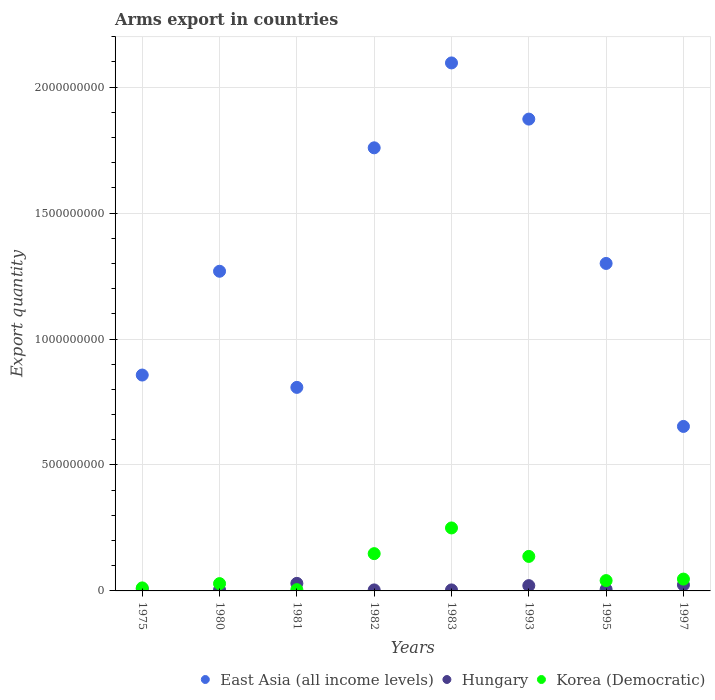What is the total arms export in Korea (Democratic) in 1975?
Your response must be concise. 1.20e+07. Across all years, what is the maximum total arms export in Korea (Democratic)?
Provide a succinct answer. 2.50e+08. Across all years, what is the minimum total arms export in Hungary?
Make the answer very short. 4.00e+06. In which year was the total arms export in East Asia (all income levels) minimum?
Your answer should be very brief. 1997. What is the total total arms export in Korea (Democratic) in the graph?
Give a very brief answer. 6.69e+08. What is the difference between the total arms export in Korea (Democratic) in 1993 and that in 1995?
Provide a succinct answer. 9.60e+07. What is the average total arms export in East Asia (all income levels) per year?
Give a very brief answer. 1.33e+09. In the year 1983, what is the difference between the total arms export in Korea (Democratic) and total arms export in Hungary?
Keep it short and to the point. 2.46e+08. In how many years, is the total arms export in Hungary greater than 500000000?
Your response must be concise. 0. What is the ratio of the total arms export in Hungary in 1980 to that in 1995?
Provide a short and direct response. 0.67. Is the total arms export in Korea (Democratic) in 1981 less than that in 1982?
Offer a very short reply. Yes. What is the difference between the highest and the second highest total arms export in Hungary?
Your answer should be compact. 6.00e+06. What is the difference between the highest and the lowest total arms export in Hungary?
Offer a terse response. 2.60e+07. In how many years, is the total arms export in Korea (Democratic) greater than the average total arms export in Korea (Democratic) taken over all years?
Your answer should be compact. 3. Is it the case that in every year, the sum of the total arms export in Hungary and total arms export in East Asia (all income levels)  is greater than the total arms export in Korea (Democratic)?
Your answer should be compact. Yes. Is the total arms export in East Asia (all income levels) strictly less than the total arms export in Hungary over the years?
Offer a very short reply. No. How many years are there in the graph?
Ensure brevity in your answer.  8. What is the difference between two consecutive major ticks on the Y-axis?
Provide a succinct answer. 5.00e+08. Are the values on the major ticks of Y-axis written in scientific E-notation?
Give a very brief answer. No. Does the graph contain any zero values?
Provide a succinct answer. No. How are the legend labels stacked?
Your answer should be compact. Horizontal. What is the title of the graph?
Provide a short and direct response. Arms export in countries. Does "Cayman Islands" appear as one of the legend labels in the graph?
Ensure brevity in your answer.  No. What is the label or title of the X-axis?
Offer a very short reply. Years. What is the label or title of the Y-axis?
Ensure brevity in your answer.  Export quantity. What is the Export quantity in East Asia (all income levels) in 1975?
Offer a terse response. 8.57e+08. What is the Export quantity in Hungary in 1975?
Offer a terse response. 8.00e+06. What is the Export quantity of East Asia (all income levels) in 1980?
Offer a very short reply. 1.27e+09. What is the Export quantity of Hungary in 1980?
Your response must be concise. 4.00e+06. What is the Export quantity of Korea (Democratic) in 1980?
Provide a succinct answer. 2.90e+07. What is the Export quantity in East Asia (all income levels) in 1981?
Ensure brevity in your answer.  8.08e+08. What is the Export quantity of Hungary in 1981?
Make the answer very short. 3.00e+07. What is the Export quantity in East Asia (all income levels) in 1982?
Keep it short and to the point. 1.76e+09. What is the Export quantity in Hungary in 1982?
Your answer should be compact. 4.00e+06. What is the Export quantity in Korea (Democratic) in 1982?
Provide a short and direct response. 1.48e+08. What is the Export quantity in East Asia (all income levels) in 1983?
Make the answer very short. 2.10e+09. What is the Export quantity of Korea (Democratic) in 1983?
Offer a terse response. 2.50e+08. What is the Export quantity of East Asia (all income levels) in 1993?
Your response must be concise. 1.87e+09. What is the Export quantity in Hungary in 1993?
Offer a very short reply. 2.10e+07. What is the Export quantity in Korea (Democratic) in 1993?
Provide a short and direct response. 1.37e+08. What is the Export quantity in East Asia (all income levels) in 1995?
Make the answer very short. 1.30e+09. What is the Export quantity in Korea (Democratic) in 1995?
Give a very brief answer. 4.10e+07. What is the Export quantity of East Asia (all income levels) in 1997?
Your answer should be compact. 6.53e+08. What is the Export quantity of Hungary in 1997?
Provide a succinct answer. 2.40e+07. What is the Export quantity of Korea (Democratic) in 1997?
Give a very brief answer. 4.70e+07. Across all years, what is the maximum Export quantity of East Asia (all income levels)?
Offer a very short reply. 2.10e+09. Across all years, what is the maximum Export quantity in Hungary?
Your response must be concise. 3.00e+07. Across all years, what is the maximum Export quantity of Korea (Democratic)?
Your response must be concise. 2.50e+08. Across all years, what is the minimum Export quantity in East Asia (all income levels)?
Your answer should be very brief. 6.53e+08. Across all years, what is the minimum Export quantity in Korea (Democratic)?
Your response must be concise. 5.00e+06. What is the total Export quantity of East Asia (all income levels) in the graph?
Provide a short and direct response. 1.06e+1. What is the total Export quantity in Hungary in the graph?
Make the answer very short. 1.01e+08. What is the total Export quantity in Korea (Democratic) in the graph?
Provide a succinct answer. 6.69e+08. What is the difference between the Export quantity in East Asia (all income levels) in 1975 and that in 1980?
Offer a terse response. -4.12e+08. What is the difference between the Export quantity in Hungary in 1975 and that in 1980?
Provide a succinct answer. 4.00e+06. What is the difference between the Export quantity of Korea (Democratic) in 1975 and that in 1980?
Ensure brevity in your answer.  -1.70e+07. What is the difference between the Export quantity in East Asia (all income levels) in 1975 and that in 1981?
Ensure brevity in your answer.  4.90e+07. What is the difference between the Export quantity in Hungary in 1975 and that in 1981?
Offer a terse response. -2.20e+07. What is the difference between the Export quantity in Korea (Democratic) in 1975 and that in 1981?
Offer a very short reply. 7.00e+06. What is the difference between the Export quantity in East Asia (all income levels) in 1975 and that in 1982?
Give a very brief answer. -9.02e+08. What is the difference between the Export quantity in Korea (Democratic) in 1975 and that in 1982?
Keep it short and to the point. -1.36e+08. What is the difference between the Export quantity in East Asia (all income levels) in 1975 and that in 1983?
Give a very brief answer. -1.24e+09. What is the difference between the Export quantity of Korea (Democratic) in 1975 and that in 1983?
Your answer should be very brief. -2.38e+08. What is the difference between the Export quantity of East Asia (all income levels) in 1975 and that in 1993?
Keep it short and to the point. -1.02e+09. What is the difference between the Export quantity in Hungary in 1975 and that in 1993?
Your answer should be compact. -1.30e+07. What is the difference between the Export quantity of Korea (Democratic) in 1975 and that in 1993?
Your answer should be very brief. -1.25e+08. What is the difference between the Export quantity in East Asia (all income levels) in 1975 and that in 1995?
Your answer should be compact. -4.43e+08. What is the difference between the Export quantity in Hungary in 1975 and that in 1995?
Offer a very short reply. 2.00e+06. What is the difference between the Export quantity of Korea (Democratic) in 1975 and that in 1995?
Provide a short and direct response. -2.90e+07. What is the difference between the Export quantity of East Asia (all income levels) in 1975 and that in 1997?
Make the answer very short. 2.04e+08. What is the difference between the Export quantity in Hungary in 1975 and that in 1997?
Provide a short and direct response. -1.60e+07. What is the difference between the Export quantity in Korea (Democratic) in 1975 and that in 1997?
Keep it short and to the point. -3.50e+07. What is the difference between the Export quantity of East Asia (all income levels) in 1980 and that in 1981?
Make the answer very short. 4.61e+08. What is the difference between the Export quantity in Hungary in 1980 and that in 1981?
Make the answer very short. -2.60e+07. What is the difference between the Export quantity of Korea (Democratic) in 1980 and that in 1981?
Make the answer very short. 2.40e+07. What is the difference between the Export quantity in East Asia (all income levels) in 1980 and that in 1982?
Your answer should be very brief. -4.90e+08. What is the difference between the Export quantity in Korea (Democratic) in 1980 and that in 1982?
Your answer should be very brief. -1.19e+08. What is the difference between the Export quantity of East Asia (all income levels) in 1980 and that in 1983?
Offer a very short reply. -8.27e+08. What is the difference between the Export quantity of Hungary in 1980 and that in 1983?
Give a very brief answer. 0. What is the difference between the Export quantity in Korea (Democratic) in 1980 and that in 1983?
Offer a terse response. -2.21e+08. What is the difference between the Export quantity in East Asia (all income levels) in 1980 and that in 1993?
Provide a succinct answer. -6.04e+08. What is the difference between the Export quantity in Hungary in 1980 and that in 1993?
Your response must be concise. -1.70e+07. What is the difference between the Export quantity of Korea (Democratic) in 1980 and that in 1993?
Offer a terse response. -1.08e+08. What is the difference between the Export quantity of East Asia (all income levels) in 1980 and that in 1995?
Offer a terse response. -3.10e+07. What is the difference between the Export quantity of Hungary in 1980 and that in 1995?
Your response must be concise. -2.00e+06. What is the difference between the Export quantity of Korea (Democratic) in 1980 and that in 1995?
Your answer should be compact. -1.20e+07. What is the difference between the Export quantity in East Asia (all income levels) in 1980 and that in 1997?
Ensure brevity in your answer.  6.16e+08. What is the difference between the Export quantity of Hungary in 1980 and that in 1997?
Provide a succinct answer. -2.00e+07. What is the difference between the Export quantity in Korea (Democratic) in 1980 and that in 1997?
Your answer should be compact. -1.80e+07. What is the difference between the Export quantity in East Asia (all income levels) in 1981 and that in 1982?
Offer a terse response. -9.51e+08. What is the difference between the Export quantity in Hungary in 1981 and that in 1982?
Keep it short and to the point. 2.60e+07. What is the difference between the Export quantity of Korea (Democratic) in 1981 and that in 1982?
Your answer should be compact. -1.43e+08. What is the difference between the Export quantity in East Asia (all income levels) in 1981 and that in 1983?
Make the answer very short. -1.29e+09. What is the difference between the Export quantity of Hungary in 1981 and that in 1983?
Offer a very short reply. 2.60e+07. What is the difference between the Export quantity of Korea (Democratic) in 1981 and that in 1983?
Provide a succinct answer. -2.45e+08. What is the difference between the Export quantity in East Asia (all income levels) in 1981 and that in 1993?
Offer a terse response. -1.06e+09. What is the difference between the Export quantity of Hungary in 1981 and that in 1993?
Make the answer very short. 9.00e+06. What is the difference between the Export quantity of Korea (Democratic) in 1981 and that in 1993?
Give a very brief answer. -1.32e+08. What is the difference between the Export quantity of East Asia (all income levels) in 1981 and that in 1995?
Provide a short and direct response. -4.92e+08. What is the difference between the Export quantity in Hungary in 1981 and that in 1995?
Provide a short and direct response. 2.40e+07. What is the difference between the Export quantity in Korea (Democratic) in 1981 and that in 1995?
Your answer should be compact. -3.60e+07. What is the difference between the Export quantity in East Asia (all income levels) in 1981 and that in 1997?
Ensure brevity in your answer.  1.55e+08. What is the difference between the Export quantity of Korea (Democratic) in 1981 and that in 1997?
Give a very brief answer. -4.20e+07. What is the difference between the Export quantity of East Asia (all income levels) in 1982 and that in 1983?
Offer a terse response. -3.37e+08. What is the difference between the Export quantity of Hungary in 1982 and that in 1983?
Your answer should be compact. 0. What is the difference between the Export quantity in Korea (Democratic) in 1982 and that in 1983?
Your response must be concise. -1.02e+08. What is the difference between the Export quantity of East Asia (all income levels) in 1982 and that in 1993?
Ensure brevity in your answer.  -1.14e+08. What is the difference between the Export quantity in Hungary in 1982 and that in 1993?
Offer a very short reply. -1.70e+07. What is the difference between the Export quantity of Korea (Democratic) in 1982 and that in 1993?
Your response must be concise. 1.10e+07. What is the difference between the Export quantity in East Asia (all income levels) in 1982 and that in 1995?
Offer a very short reply. 4.59e+08. What is the difference between the Export quantity of Korea (Democratic) in 1982 and that in 1995?
Your answer should be compact. 1.07e+08. What is the difference between the Export quantity of East Asia (all income levels) in 1982 and that in 1997?
Your answer should be compact. 1.11e+09. What is the difference between the Export quantity in Hungary in 1982 and that in 1997?
Your answer should be very brief. -2.00e+07. What is the difference between the Export quantity of Korea (Democratic) in 1982 and that in 1997?
Provide a short and direct response. 1.01e+08. What is the difference between the Export quantity in East Asia (all income levels) in 1983 and that in 1993?
Your answer should be compact. 2.23e+08. What is the difference between the Export quantity in Hungary in 1983 and that in 1993?
Offer a terse response. -1.70e+07. What is the difference between the Export quantity of Korea (Democratic) in 1983 and that in 1993?
Offer a terse response. 1.13e+08. What is the difference between the Export quantity in East Asia (all income levels) in 1983 and that in 1995?
Offer a very short reply. 7.96e+08. What is the difference between the Export quantity of Korea (Democratic) in 1983 and that in 1995?
Provide a succinct answer. 2.09e+08. What is the difference between the Export quantity of East Asia (all income levels) in 1983 and that in 1997?
Offer a terse response. 1.44e+09. What is the difference between the Export quantity of Hungary in 1983 and that in 1997?
Offer a terse response. -2.00e+07. What is the difference between the Export quantity of Korea (Democratic) in 1983 and that in 1997?
Ensure brevity in your answer.  2.03e+08. What is the difference between the Export quantity in East Asia (all income levels) in 1993 and that in 1995?
Make the answer very short. 5.73e+08. What is the difference between the Export quantity in Hungary in 1993 and that in 1995?
Your answer should be very brief. 1.50e+07. What is the difference between the Export quantity in Korea (Democratic) in 1993 and that in 1995?
Provide a short and direct response. 9.60e+07. What is the difference between the Export quantity of East Asia (all income levels) in 1993 and that in 1997?
Keep it short and to the point. 1.22e+09. What is the difference between the Export quantity in Hungary in 1993 and that in 1997?
Keep it short and to the point. -3.00e+06. What is the difference between the Export quantity of Korea (Democratic) in 1993 and that in 1997?
Make the answer very short. 9.00e+07. What is the difference between the Export quantity of East Asia (all income levels) in 1995 and that in 1997?
Offer a very short reply. 6.47e+08. What is the difference between the Export quantity of Hungary in 1995 and that in 1997?
Provide a succinct answer. -1.80e+07. What is the difference between the Export quantity of Korea (Democratic) in 1995 and that in 1997?
Ensure brevity in your answer.  -6.00e+06. What is the difference between the Export quantity in East Asia (all income levels) in 1975 and the Export quantity in Hungary in 1980?
Offer a terse response. 8.53e+08. What is the difference between the Export quantity of East Asia (all income levels) in 1975 and the Export quantity of Korea (Democratic) in 1980?
Make the answer very short. 8.28e+08. What is the difference between the Export quantity of Hungary in 1975 and the Export quantity of Korea (Democratic) in 1980?
Offer a terse response. -2.10e+07. What is the difference between the Export quantity in East Asia (all income levels) in 1975 and the Export quantity in Hungary in 1981?
Give a very brief answer. 8.27e+08. What is the difference between the Export quantity of East Asia (all income levels) in 1975 and the Export quantity of Korea (Democratic) in 1981?
Offer a very short reply. 8.52e+08. What is the difference between the Export quantity of Hungary in 1975 and the Export quantity of Korea (Democratic) in 1981?
Your response must be concise. 3.00e+06. What is the difference between the Export quantity in East Asia (all income levels) in 1975 and the Export quantity in Hungary in 1982?
Offer a terse response. 8.53e+08. What is the difference between the Export quantity in East Asia (all income levels) in 1975 and the Export quantity in Korea (Democratic) in 1982?
Provide a succinct answer. 7.09e+08. What is the difference between the Export quantity of Hungary in 1975 and the Export quantity of Korea (Democratic) in 1982?
Provide a succinct answer. -1.40e+08. What is the difference between the Export quantity of East Asia (all income levels) in 1975 and the Export quantity of Hungary in 1983?
Give a very brief answer. 8.53e+08. What is the difference between the Export quantity in East Asia (all income levels) in 1975 and the Export quantity in Korea (Democratic) in 1983?
Offer a terse response. 6.07e+08. What is the difference between the Export quantity of Hungary in 1975 and the Export quantity of Korea (Democratic) in 1983?
Provide a succinct answer. -2.42e+08. What is the difference between the Export quantity in East Asia (all income levels) in 1975 and the Export quantity in Hungary in 1993?
Provide a short and direct response. 8.36e+08. What is the difference between the Export quantity in East Asia (all income levels) in 1975 and the Export quantity in Korea (Democratic) in 1993?
Your answer should be compact. 7.20e+08. What is the difference between the Export quantity of Hungary in 1975 and the Export quantity of Korea (Democratic) in 1993?
Offer a terse response. -1.29e+08. What is the difference between the Export quantity of East Asia (all income levels) in 1975 and the Export quantity of Hungary in 1995?
Your answer should be very brief. 8.51e+08. What is the difference between the Export quantity of East Asia (all income levels) in 1975 and the Export quantity of Korea (Democratic) in 1995?
Your answer should be compact. 8.16e+08. What is the difference between the Export quantity of Hungary in 1975 and the Export quantity of Korea (Democratic) in 1995?
Offer a very short reply. -3.30e+07. What is the difference between the Export quantity of East Asia (all income levels) in 1975 and the Export quantity of Hungary in 1997?
Your answer should be compact. 8.33e+08. What is the difference between the Export quantity of East Asia (all income levels) in 1975 and the Export quantity of Korea (Democratic) in 1997?
Offer a terse response. 8.10e+08. What is the difference between the Export quantity in Hungary in 1975 and the Export quantity in Korea (Democratic) in 1997?
Provide a succinct answer. -3.90e+07. What is the difference between the Export quantity in East Asia (all income levels) in 1980 and the Export quantity in Hungary in 1981?
Your answer should be very brief. 1.24e+09. What is the difference between the Export quantity in East Asia (all income levels) in 1980 and the Export quantity in Korea (Democratic) in 1981?
Offer a terse response. 1.26e+09. What is the difference between the Export quantity in East Asia (all income levels) in 1980 and the Export quantity in Hungary in 1982?
Provide a succinct answer. 1.26e+09. What is the difference between the Export quantity in East Asia (all income levels) in 1980 and the Export quantity in Korea (Democratic) in 1982?
Your answer should be compact. 1.12e+09. What is the difference between the Export quantity of Hungary in 1980 and the Export quantity of Korea (Democratic) in 1982?
Provide a succinct answer. -1.44e+08. What is the difference between the Export quantity of East Asia (all income levels) in 1980 and the Export quantity of Hungary in 1983?
Offer a terse response. 1.26e+09. What is the difference between the Export quantity in East Asia (all income levels) in 1980 and the Export quantity in Korea (Democratic) in 1983?
Your answer should be compact. 1.02e+09. What is the difference between the Export quantity of Hungary in 1980 and the Export quantity of Korea (Democratic) in 1983?
Your answer should be very brief. -2.46e+08. What is the difference between the Export quantity in East Asia (all income levels) in 1980 and the Export quantity in Hungary in 1993?
Keep it short and to the point. 1.25e+09. What is the difference between the Export quantity in East Asia (all income levels) in 1980 and the Export quantity in Korea (Democratic) in 1993?
Provide a short and direct response. 1.13e+09. What is the difference between the Export quantity in Hungary in 1980 and the Export quantity in Korea (Democratic) in 1993?
Keep it short and to the point. -1.33e+08. What is the difference between the Export quantity in East Asia (all income levels) in 1980 and the Export quantity in Hungary in 1995?
Make the answer very short. 1.26e+09. What is the difference between the Export quantity in East Asia (all income levels) in 1980 and the Export quantity in Korea (Democratic) in 1995?
Provide a short and direct response. 1.23e+09. What is the difference between the Export quantity in Hungary in 1980 and the Export quantity in Korea (Democratic) in 1995?
Your response must be concise. -3.70e+07. What is the difference between the Export quantity in East Asia (all income levels) in 1980 and the Export quantity in Hungary in 1997?
Give a very brief answer. 1.24e+09. What is the difference between the Export quantity of East Asia (all income levels) in 1980 and the Export quantity of Korea (Democratic) in 1997?
Your response must be concise. 1.22e+09. What is the difference between the Export quantity of Hungary in 1980 and the Export quantity of Korea (Democratic) in 1997?
Make the answer very short. -4.30e+07. What is the difference between the Export quantity in East Asia (all income levels) in 1981 and the Export quantity in Hungary in 1982?
Offer a very short reply. 8.04e+08. What is the difference between the Export quantity in East Asia (all income levels) in 1981 and the Export quantity in Korea (Democratic) in 1982?
Your answer should be very brief. 6.60e+08. What is the difference between the Export quantity in Hungary in 1981 and the Export quantity in Korea (Democratic) in 1982?
Make the answer very short. -1.18e+08. What is the difference between the Export quantity of East Asia (all income levels) in 1981 and the Export quantity of Hungary in 1983?
Make the answer very short. 8.04e+08. What is the difference between the Export quantity in East Asia (all income levels) in 1981 and the Export quantity in Korea (Democratic) in 1983?
Make the answer very short. 5.58e+08. What is the difference between the Export quantity of Hungary in 1981 and the Export quantity of Korea (Democratic) in 1983?
Make the answer very short. -2.20e+08. What is the difference between the Export quantity of East Asia (all income levels) in 1981 and the Export quantity of Hungary in 1993?
Provide a succinct answer. 7.87e+08. What is the difference between the Export quantity in East Asia (all income levels) in 1981 and the Export quantity in Korea (Democratic) in 1993?
Offer a terse response. 6.71e+08. What is the difference between the Export quantity in Hungary in 1981 and the Export quantity in Korea (Democratic) in 1993?
Your answer should be very brief. -1.07e+08. What is the difference between the Export quantity in East Asia (all income levels) in 1981 and the Export quantity in Hungary in 1995?
Your response must be concise. 8.02e+08. What is the difference between the Export quantity in East Asia (all income levels) in 1981 and the Export quantity in Korea (Democratic) in 1995?
Offer a terse response. 7.67e+08. What is the difference between the Export quantity in Hungary in 1981 and the Export quantity in Korea (Democratic) in 1995?
Offer a terse response. -1.10e+07. What is the difference between the Export quantity in East Asia (all income levels) in 1981 and the Export quantity in Hungary in 1997?
Your response must be concise. 7.84e+08. What is the difference between the Export quantity in East Asia (all income levels) in 1981 and the Export quantity in Korea (Democratic) in 1997?
Give a very brief answer. 7.61e+08. What is the difference between the Export quantity in Hungary in 1981 and the Export quantity in Korea (Democratic) in 1997?
Make the answer very short. -1.70e+07. What is the difference between the Export quantity in East Asia (all income levels) in 1982 and the Export quantity in Hungary in 1983?
Keep it short and to the point. 1.76e+09. What is the difference between the Export quantity in East Asia (all income levels) in 1982 and the Export quantity in Korea (Democratic) in 1983?
Make the answer very short. 1.51e+09. What is the difference between the Export quantity of Hungary in 1982 and the Export quantity of Korea (Democratic) in 1983?
Make the answer very short. -2.46e+08. What is the difference between the Export quantity in East Asia (all income levels) in 1982 and the Export quantity in Hungary in 1993?
Give a very brief answer. 1.74e+09. What is the difference between the Export quantity in East Asia (all income levels) in 1982 and the Export quantity in Korea (Democratic) in 1993?
Your response must be concise. 1.62e+09. What is the difference between the Export quantity in Hungary in 1982 and the Export quantity in Korea (Democratic) in 1993?
Offer a terse response. -1.33e+08. What is the difference between the Export quantity in East Asia (all income levels) in 1982 and the Export quantity in Hungary in 1995?
Your response must be concise. 1.75e+09. What is the difference between the Export quantity of East Asia (all income levels) in 1982 and the Export quantity of Korea (Democratic) in 1995?
Keep it short and to the point. 1.72e+09. What is the difference between the Export quantity of Hungary in 1982 and the Export quantity of Korea (Democratic) in 1995?
Ensure brevity in your answer.  -3.70e+07. What is the difference between the Export quantity in East Asia (all income levels) in 1982 and the Export quantity in Hungary in 1997?
Provide a succinct answer. 1.74e+09. What is the difference between the Export quantity in East Asia (all income levels) in 1982 and the Export quantity in Korea (Democratic) in 1997?
Your answer should be very brief. 1.71e+09. What is the difference between the Export quantity in Hungary in 1982 and the Export quantity in Korea (Democratic) in 1997?
Your response must be concise. -4.30e+07. What is the difference between the Export quantity of East Asia (all income levels) in 1983 and the Export quantity of Hungary in 1993?
Make the answer very short. 2.08e+09. What is the difference between the Export quantity in East Asia (all income levels) in 1983 and the Export quantity in Korea (Democratic) in 1993?
Your answer should be very brief. 1.96e+09. What is the difference between the Export quantity in Hungary in 1983 and the Export quantity in Korea (Democratic) in 1993?
Offer a terse response. -1.33e+08. What is the difference between the Export quantity in East Asia (all income levels) in 1983 and the Export quantity in Hungary in 1995?
Offer a terse response. 2.09e+09. What is the difference between the Export quantity of East Asia (all income levels) in 1983 and the Export quantity of Korea (Democratic) in 1995?
Your response must be concise. 2.06e+09. What is the difference between the Export quantity of Hungary in 1983 and the Export quantity of Korea (Democratic) in 1995?
Your answer should be compact. -3.70e+07. What is the difference between the Export quantity of East Asia (all income levels) in 1983 and the Export quantity of Hungary in 1997?
Offer a terse response. 2.07e+09. What is the difference between the Export quantity of East Asia (all income levels) in 1983 and the Export quantity of Korea (Democratic) in 1997?
Offer a very short reply. 2.05e+09. What is the difference between the Export quantity in Hungary in 1983 and the Export quantity in Korea (Democratic) in 1997?
Your answer should be compact. -4.30e+07. What is the difference between the Export quantity of East Asia (all income levels) in 1993 and the Export quantity of Hungary in 1995?
Offer a very short reply. 1.87e+09. What is the difference between the Export quantity of East Asia (all income levels) in 1993 and the Export quantity of Korea (Democratic) in 1995?
Ensure brevity in your answer.  1.83e+09. What is the difference between the Export quantity in Hungary in 1993 and the Export quantity in Korea (Democratic) in 1995?
Ensure brevity in your answer.  -2.00e+07. What is the difference between the Export quantity in East Asia (all income levels) in 1993 and the Export quantity in Hungary in 1997?
Offer a terse response. 1.85e+09. What is the difference between the Export quantity of East Asia (all income levels) in 1993 and the Export quantity of Korea (Democratic) in 1997?
Your answer should be compact. 1.83e+09. What is the difference between the Export quantity in Hungary in 1993 and the Export quantity in Korea (Democratic) in 1997?
Your answer should be very brief. -2.60e+07. What is the difference between the Export quantity in East Asia (all income levels) in 1995 and the Export quantity in Hungary in 1997?
Keep it short and to the point. 1.28e+09. What is the difference between the Export quantity of East Asia (all income levels) in 1995 and the Export quantity of Korea (Democratic) in 1997?
Provide a succinct answer. 1.25e+09. What is the difference between the Export quantity of Hungary in 1995 and the Export quantity of Korea (Democratic) in 1997?
Offer a very short reply. -4.10e+07. What is the average Export quantity of East Asia (all income levels) per year?
Your response must be concise. 1.33e+09. What is the average Export quantity in Hungary per year?
Provide a succinct answer. 1.26e+07. What is the average Export quantity of Korea (Democratic) per year?
Make the answer very short. 8.36e+07. In the year 1975, what is the difference between the Export quantity of East Asia (all income levels) and Export quantity of Hungary?
Provide a short and direct response. 8.49e+08. In the year 1975, what is the difference between the Export quantity of East Asia (all income levels) and Export quantity of Korea (Democratic)?
Keep it short and to the point. 8.45e+08. In the year 1975, what is the difference between the Export quantity in Hungary and Export quantity in Korea (Democratic)?
Your answer should be very brief. -4.00e+06. In the year 1980, what is the difference between the Export quantity of East Asia (all income levels) and Export quantity of Hungary?
Offer a very short reply. 1.26e+09. In the year 1980, what is the difference between the Export quantity in East Asia (all income levels) and Export quantity in Korea (Democratic)?
Offer a very short reply. 1.24e+09. In the year 1980, what is the difference between the Export quantity in Hungary and Export quantity in Korea (Democratic)?
Your answer should be compact. -2.50e+07. In the year 1981, what is the difference between the Export quantity of East Asia (all income levels) and Export quantity of Hungary?
Your answer should be compact. 7.78e+08. In the year 1981, what is the difference between the Export quantity in East Asia (all income levels) and Export quantity in Korea (Democratic)?
Offer a terse response. 8.03e+08. In the year 1981, what is the difference between the Export quantity in Hungary and Export quantity in Korea (Democratic)?
Make the answer very short. 2.50e+07. In the year 1982, what is the difference between the Export quantity of East Asia (all income levels) and Export quantity of Hungary?
Give a very brief answer. 1.76e+09. In the year 1982, what is the difference between the Export quantity of East Asia (all income levels) and Export quantity of Korea (Democratic)?
Offer a very short reply. 1.61e+09. In the year 1982, what is the difference between the Export quantity of Hungary and Export quantity of Korea (Democratic)?
Provide a succinct answer. -1.44e+08. In the year 1983, what is the difference between the Export quantity of East Asia (all income levels) and Export quantity of Hungary?
Your answer should be compact. 2.09e+09. In the year 1983, what is the difference between the Export quantity in East Asia (all income levels) and Export quantity in Korea (Democratic)?
Your answer should be compact. 1.85e+09. In the year 1983, what is the difference between the Export quantity of Hungary and Export quantity of Korea (Democratic)?
Make the answer very short. -2.46e+08. In the year 1993, what is the difference between the Export quantity in East Asia (all income levels) and Export quantity in Hungary?
Your answer should be compact. 1.85e+09. In the year 1993, what is the difference between the Export quantity in East Asia (all income levels) and Export quantity in Korea (Democratic)?
Your answer should be very brief. 1.74e+09. In the year 1993, what is the difference between the Export quantity of Hungary and Export quantity of Korea (Democratic)?
Your response must be concise. -1.16e+08. In the year 1995, what is the difference between the Export quantity in East Asia (all income levels) and Export quantity in Hungary?
Give a very brief answer. 1.29e+09. In the year 1995, what is the difference between the Export quantity of East Asia (all income levels) and Export quantity of Korea (Democratic)?
Offer a terse response. 1.26e+09. In the year 1995, what is the difference between the Export quantity of Hungary and Export quantity of Korea (Democratic)?
Offer a terse response. -3.50e+07. In the year 1997, what is the difference between the Export quantity in East Asia (all income levels) and Export quantity in Hungary?
Offer a very short reply. 6.29e+08. In the year 1997, what is the difference between the Export quantity of East Asia (all income levels) and Export quantity of Korea (Democratic)?
Keep it short and to the point. 6.06e+08. In the year 1997, what is the difference between the Export quantity of Hungary and Export quantity of Korea (Democratic)?
Offer a terse response. -2.30e+07. What is the ratio of the Export quantity in East Asia (all income levels) in 1975 to that in 1980?
Your answer should be very brief. 0.68. What is the ratio of the Export quantity in Hungary in 1975 to that in 1980?
Ensure brevity in your answer.  2. What is the ratio of the Export quantity of Korea (Democratic) in 1975 to that in 1980?
Your response must be concise. 0.41. What is the ratio of the Export quantity of East Asia (all income levels) in 1975 to that in 1981?
Give a very brief answer. 1.06. What is the ratio of the Export quantity of Hungary in 1975 to that in 1981?
Give a very brief answer. 0.27. What is the ratio of the Export quantity in Korea (Democratic) in 1975 to that in 1981?
Offer a terse response. 2.4. What is the ratio of the Export quantity in East Asia (all income levels) in 1975 to that in 1982?
Give a very brief answer. 0.49. What is the ratio of the Export quantity of Hungary in 1975 to that in 1982?
Your answer should be compact. 2. What is the ratio of the Export quantity of Korea (Democratic) in 1975 to that in 1982?
Keep it short and to the point. 0.08. What is the ratio of the Export quantity of East Asia (all income levels) in 1975 to that in 1983?
Your answer should be very brief. 0.41. What is the ratio of the Export quantity of Korea (Democratic) in 1975 to that in 1983?
Provide a short and direct response. 0.05. What is the ratio of the Export quantity in East Asia (all income levels) in 1975 to that in 1993?
Your response must be concise. 0.46. What is the ratio of the Export quantity of Hungary in 1975 to that in 1993?
Give a very brief answer. 0.38. What is the ratio of the Export quantity of Korea (Democratic) in 1975 to that in 1993?
Make the answer very short. 0.09. What is the ratio of the Export quantity in East Asia (all income levels) in 1975 to that in 1995?
Your response must be concise. 0.66. What is the ratio of the Export quantity in Hungary in 1975 to that in 1995?
Keep it short and to the point. 1.33. What is the ratio of the Export quantity in Korea (Democratic) in 1975 to that in 1995?
Provide a succinct answer. 0.29. What is the ratio of the Export quantity in East Asia (all income levels) in 1975 to that in 1997?
Your answer should be very brief. 1.31. What is the ratio of the Export quantity in Hungary in 1975 to that in 1997?
Offer a very short reply. 0.33. What is the ratio of the Export quantity in Korea (Democratic) in 1975 to that in 1997?
Ensure brevity in your answer.  0.26. What is the ratio of the Export quantity in East Asia (all income levels) in 1980 to that in 1981?
Make the answer very short. 1.57. What is the ratio of the Export quantity of Hungary in 1980 to that in 1981?
Your answer should be very brief. 0.13. What is the ratio of the Export quantity in East Asia (all income levels) in 1980 to that in 1982?
Offer a very short reply. 0.72. What is the ratio of the Export quantity in Korea (Democratic) in 1980 to that in 1982?
Ensure brevity in your answer.  0.2. What is the ratio of the Export quantity in East Asia (all income levels) in 1980 to that in 1983?
Offer a very short reply. 0.61. What is the ratio of the Export quantity in Korea (Democratic) in 1980 to that in 1983?
Your response must be concise. 0.12. What is the ratio of the Export quantity of East Asia (all income levels) in 1980 to that in 1993?
Keep it short and to the point. 0.68. What is the ratio of the Export quantity in Hungary in 1980 to that in 1993?
Ensure brevity in your answer.  0.19. What is the ratio of the Export quantity in Korea (Democratic) in 1980 to that in 1993?
Your answer should be very brief. 0.21. What is the ratio of the Export quantity of East Asia (all income levels) in 1980 to that in 1995?
Your response must be concise. 0.98. What is the ratio of the Export quantity in Korea (Democratic) in 1980 to that in 1995?
Make the answer very short. 0.71. What is the ratio of the Export quantity of East Asia (all income levels) in 1980 to that in 1997?
Provide a short and direct response. 1.94. What is the ratio of the Export quantity in Hungary in 1980 to that in 1997?
Your answer should be very brief. 0.17. What is the ratio of the Export quantity of Korea (Democratic) in 1980 to that in 1997?
Ensure brevity in your answer.  0.62. What is the ratio of the Export quantity of East Asia (all income levels) in 1981 to that in 1982?
Offer a very short reply. 0.46. What is the ratio of the Export quantity of Hungary in 1981 to that in 1982?
Offer a terse response. 7.5. What is the ratio of the Export quantity of Korea (Democratic) in 1981 to that in 1982?
Your answer should be very brief. 0.03. What is the ratio of the Export quantity in East Asia (all income levels) in 1981 to that in 1983?
Provide a short and direct response. 0.39. What is the ratio of the Export quantity of Korea (Democratic) in 1981 to that in 1983?
Provide a succinct answer. 0.02. What is the ratio of the Export quantity of East Asia (all income levels) in 1981 to that in 1993?
Give a very brief answer. 0.43. What is the ratio of the Export quantity in Hungary in 1981 to that in 1993?
Give a very brief answer. 1.43. What is the ratio of the Export quantity in Korea (Democratic) in 1981 to that in 1993?
Offer a terse response. 0.04. What is the ratio of the Export quantity in East Asia (all income levels) in 1981 to that in 1995?
Ensure brevity in your answer.  0.62. What is the ratio of the Export quantity in Hungary in 1981 to that in 1995?
Your answer should be compact. 5. What is the ratio of the Export quantity of Korea (Democratic) in 1981 to that in 1995?
Give a very brief answer. 0.12. What is the ratio of the Export quantity in East Asia (all income levels) in 1981 to that in 1997?
Ensure brevity in your answer.  1.24. What is the ratio of the Export quantity in Korea (Democratic) in 1981 to that in 1997?
Provide a short and direct response. 0.11. What is the ratio of the Export quantity of East Asia (all income levels) in 1982 to that in 1983?
Provide a short and direct response. 0.84. What is the ratio of the Export quantity in Hungary in 1982 to that in 1983?
Give a very brief answer. 1. What is the ratio of the Export quantity of Korea (Democratic) in 1982 to that in 1983?
Offer a terse response. 0.59. What is the ratio of the Export quantity in East Asia (all income levels) in 1982 to that in 1993?
Your answer should be very brief. 0.94. What is the ratio of the Export quantity of Hungary in 1982 to that in 1993?
Keep it short and to the point. 0.19. What is the ratio of the Export quantity in Korea (Democratic) in 1982 to that in 1993?
Provide a short and direct response. 1.08. What is the ratio of the Export quantity in East Asia (all income levels) in 1982 to that in 1995?
Your response must be concise. 1.35. What is the ratio of the Export quantity of Hungary in 1982 to that in 1995?
Make the answer very short. 0.67. What is the ratio of the Export quantity of Korea (Democratic) in 1982 to that in 1995?
Offer a very short reply. 3.61. What is the ratio of the Export quantity in East Asia (all income levels) in 1982 to that in 1997?
Offer a very short reply. 2.69. What is the ratio of the Export quantity of Hungary in 1982 to that in 1997?
Offer a very short reply. 0.17. What is the ratio of the Export quantity of Korea (Democratic) in 1982 to that in 1997?
Offer a terse response. 3.15. What is the ratio of the Export quantity in East Asia (all income levels) in 1983 to that in 1993?
Offer a terse response. 1.12. What is the ratio of the Export quantity in Hungary in 1983 to that in 1993?
Keep it short and to the point. 0.19. What is the ratio of the Export quantity in Korea (Democratic) in 1983 to that in 1993?
Make the answer very short. 1.82. What is the ratio of the Export quantity in East Asia (all income levels) in 1983 to that in 1995?
Offer a very short reply. 1.61. What is the ratio of the Export quantity in Hungary in 1983 to that in 1995?
Your answer should be compact. 0.67. What is the ratio of the Export quantity of Korea (Democratic) in 1983 to that in 1995?
Provide a short and direct response. 6.1. What is the ratio of the Export quantity of East Asia (all income levels) in 1983 to that in 1997?
Give a very brief answer. 3.21. What is the ratio of the Export quantity in Korea (Democratic) in 1983 to that in 1997?
Your response must be concise. 5.32. What is the ratio of the Export quantity in East Asia (all income levels) in 1993 to that in 1995?
Your answer should be compact. 1.44. What is the ratio of the Export quantity in Korea (Democratic) in 1993 to that in 1995?
Make the answer very short. 3.34. What is the ratio of the Export quantity of East Asia (all income levels) in 1993 to that in 1997?
Ensure brevity in your answer.  2.87. What is the ratio of the Export quantity of Korea (Democratic) in 1993 to that in 1997?
Your answer should be very brief. 2.91. What is the ratio of the Export quantity of East Asia (all income levels) in 1995 to that in 1997?
Keep it short and to the point. 1.99. What is the ratio of the Export quantity of Hungary in 1995 to that in 1997?
Keep it short and to the point. 0.25. What is the ratio of the Export quantity in Korea (Democratic) in 1995 to that in 1997?
Ensure brevity in your answer.  0.87. What is the difference between the highest and the second highest Export quantity of East Asia (all income levels)?
Keep it short and to the point. 2.23e+08. What is the difference between the highest and the second highest Export quantity in Hungary?
Offer a very short reply. 6.00e+06. What is the difference between the highest and the second highest Export quantity of Korea (Democratic)?
Your response must be concise. 1.02e+08. What is the difference between the highest and the lowest Export quantity of East Asia (all income levels)?
Offer a very short reply. 1.44e+09. What is the difference between the highest and the lowest Export quantity in Hungary?
Provide a succinct answer. 2.60e+07. What is the difference between the highest and the lowest Export quantity in Korea (Democratic)?
Make the answer very short. 2.45e+08. 